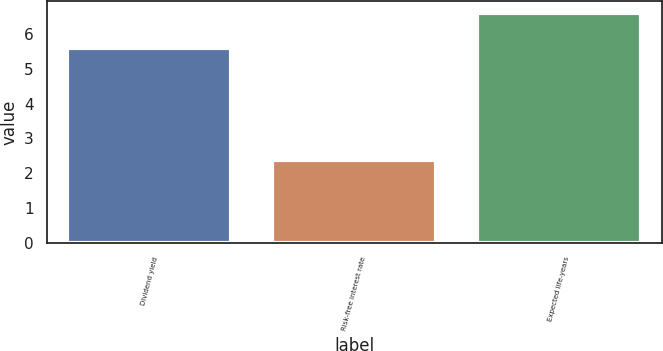Convert chart to OTSL. <chart><loc_0><loc_0><loc_500><loc_500><bar_chart><fcel>Dividend yield<fcel>Risk-free interest rate<fcel>Expected life-years<nl><fcel>5.6<fcel>2.39<fcel>6.6<nl></chart> 